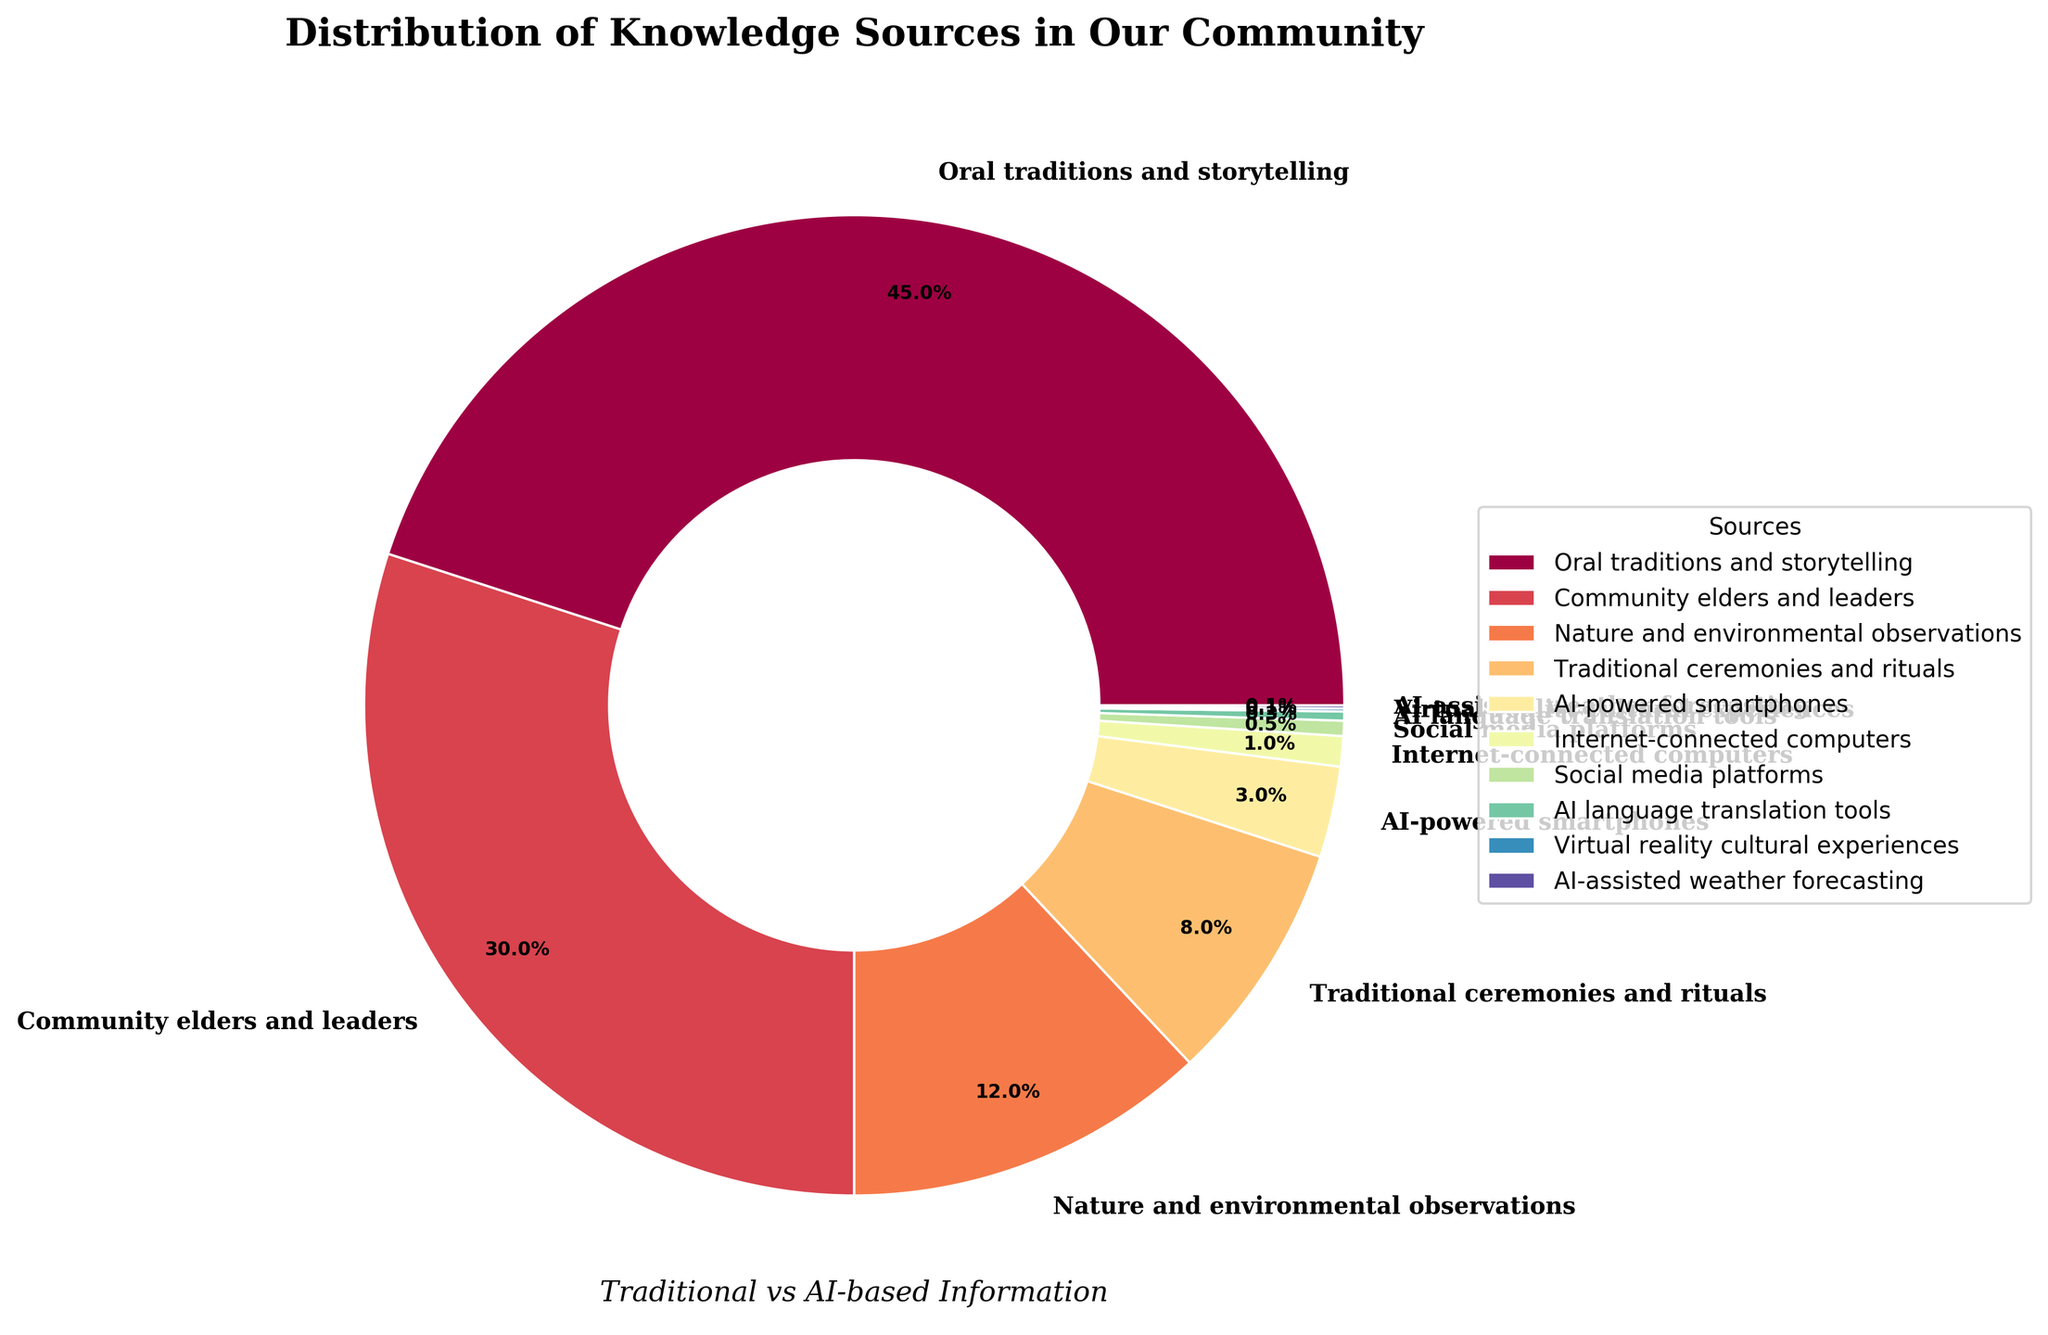What is the largest source of traditional knowledge in the community according to the pie chart? The pie chart shows that "Oral traditions and storytelling" has the highest percentage value. By looking at the chart, we see that it occupies the largest section with 45%.
Answer: Oral traditions and storytelling How much more popular are community elders and leaders as a source compared to nature and environmental observations? By examining the chart, we determine the percentages: "Community elders and leaders" is 30%, and "Nature and environmental observations" is 12%. The difference is calculated by subtracting the smaller percentage from the larger one, which is 30% - 12% = 18%.
Answer: 18% What is the combined percentage of traditional ceremonies and rituals and AI-powered smartphones? Adding the percentage for "Traditional ceremonies and rituals" (8%) and "AI-powered smartphones" (3%), we get the combined value: 8% + 3% = 11%.
Answer: 11% Which source has the smallest percentage on the pie chart and what is its value? The smallest segment on the pie chart represents "Virtual reality cultural experiences" and "AI-assisted weather forecasting," both with a percentage of 0.1%.
Answer: Virtual reality cultural experiences and AI-assisted weather forecasting, 0.1% How do the percentages of traditional knowledge sources (oral traditions, community elders, nature observations, and ceremonies) compare to AI-based sources (smartphones, computers, social media, and others)? Summing up the percentages for traditional knowledge sources: Oral traditions (45%), Community elders (30%), Nature observations (12%), Ceremonies (8%) gives 45% + 30% + 12% + 8% = 95%. Summing up the percentages for AI-based sources: Smartphones (3%), Computers (1%), Social media (0.5%), Translation tools (0.3%), Virtual reality (0.1%), Weather forecasting (0.1%) gives 3% + 1% + 0.5% + 0.3% + 0.1% + 0.1% = 5%. Clearly, traditional sources have a much higher combined percentage (95%) compared to AI-based sources (5%).
Answer: Traditional sources: 95%, AI-based sources: 5% Which traditional knowledge source is closest in percentage to AI-powered smartphones? The chart indicates the percentages for all sources. Comparing them, "Traditional ceremonies and rituals" is at 8%, while "AI-powered smartphones" are at 3%. The closest higher percentage to 3% is "Nature and environmental observations" at 12%. Therefore, none of the traditional sources are very close, but "Nature and environmental observations" is relatively the closest higher percentage.
Answer: Nature and environmental observations What is the combined percentage of all AI-based sources? Summing all AI-based sources: AI-powered smartphones (3%), Internet-connected computers (1%), Social media platforms (0.5%), AI language translation tools (0.3%), Virtual reality cultural experiences (0.1%), and AI-assisted weather forecasting (0.1%). The calculation is 3% + 1% + 0.5% + 0.3% + 0.1% + 0.1% = 5%.
Answer: 5% How much larger is the section for community elders and leaders compared to social media platforms? "Community elders and leaders" occupy 30%, and "Social media platforms" 0.5%. The difference is 30% - 0.5% = 29.5%.
Answer: 29.5% Considering all traditional knowledge sources, what is their average percentage contribution? Traditional knowledge sources are: Oral traditions and storytelling (45%), Community elders and leaders (30%), Nature and environmental observations (12%), Traditional ceremonies and rituals (8%). The sum is 45% + 30% + 12% + 8% = 95%, and the average is 95% / 4 = 23.75%.
Answer: 23.75% 